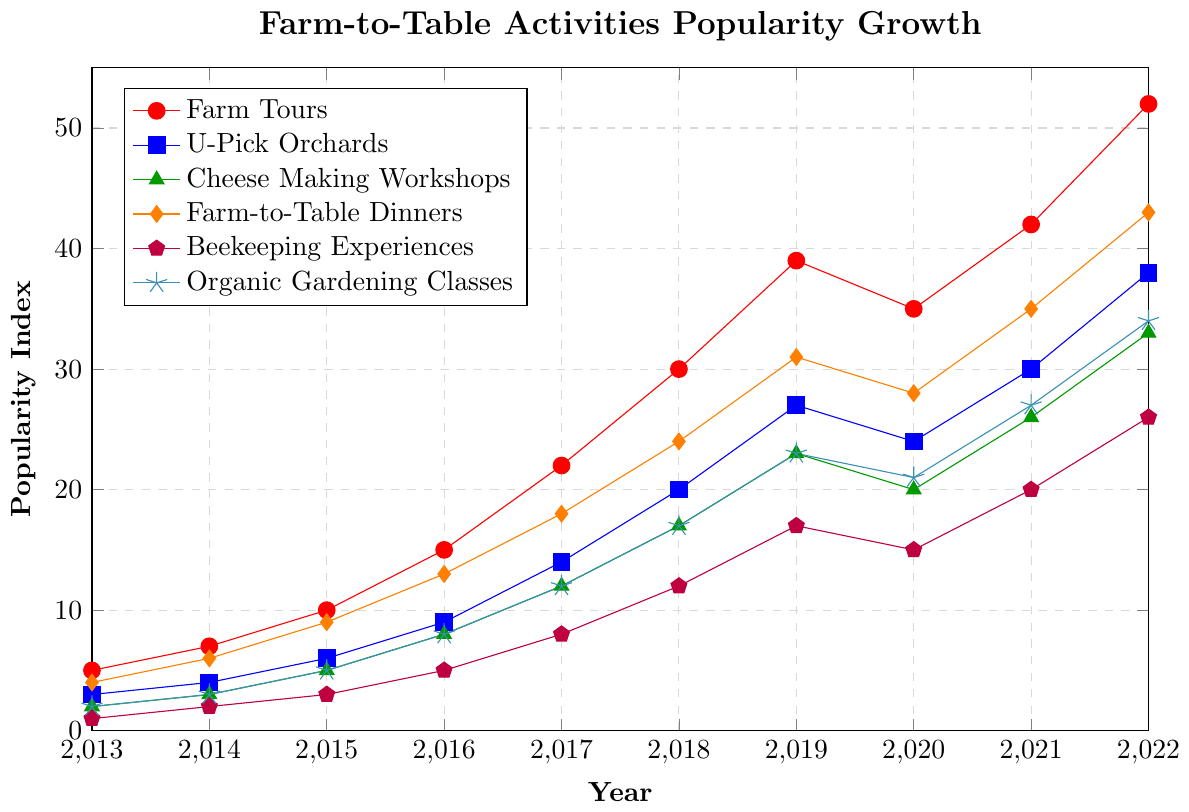Which activity experienced the greatest increase in popularity between 2013 and 2022? To find the activity with the greatest increase in popularity, calculate the difference between the 2022 and 2013 popularity indices for each activity. Farm Tours: 52-5=47, U-Pick Orchards: 38-3=35, Cheese Making Workshops: 33-2=31, Farm-to-Table Dinners: 43-4=39, Beekeeping Experiences: 26-1=25, Organic Gardening Classes: 34-2=32. Farm Tours have the highest increase.
Answer: Farm Tours Which year saw a significant decline in popularity for Farm Tours? By comparing the points for Farm Tours, there is a noticeable decline from 2019 (39) to 2020 (35).
Answer: 2020 What is the popularity index difference between U-Pick Orchards and Cheese Making Workshops in 2022? Subtract the popularity index of Cheese Making Workshops from U-Pick Orchards for 2022. U-Pick Orchards: 38, Cheese Making Workshops: 33. The difference is 38-33=5
Answer: 5 Which activities have exactly the same popularity index at any year? By visually inspecting the lines, no two activities have exactly the same index at any specific year throughout the chart.
Answer: None How did the popularity of Beekeeping Experiences change from 2013 to 2022? Subtract the 2013 value from the 2022 value for Beekeeping Experiences. 26-1=25. The popularity increased by 25 units.
Answer: Increased by 25 units In which years did Organic Gardening Classes surpass the 20 popularity index mark? Visually examining the plot, Organic Gardening Classes surpassed a popularity index of 20 starting from 2019 onward.
Answer: 2019, 2020, 2021, 2022 What is the approximate average annual growth rate of Farm-to-Table Dinners from 2013 to 2022? To find the average annual growth rate, take the difference between 2022 and 2013 popularity values and divide by the number of years (2022-2013). (43-4)/ (2022-2013) = 39/9 ≈ 4.33. The average annual growth rate is approximately 4.33.
Answer: 4.33 Which two activities had the closest popularity indices in 2020? By comparing the 2020 values: Farm Tours (35), U-Pick Orchards (24), Cheese Making Workshops (20), Farm-to-Table Dinners (28), Beekeeping Experiences (15), and Organic Gardening Classes (21). Cheese Making Workshops and Organic Gardening Classes are the closest with 20 and 21, respectively.
Answer: Cheese Making Workshops and Organic Gardening Classes What was the trend of Cheese Making Workshops' popularity over the decade? Visually inspecting the trend, the popularity increased steadily each year with no declines.
Answer: Steadily increasing 